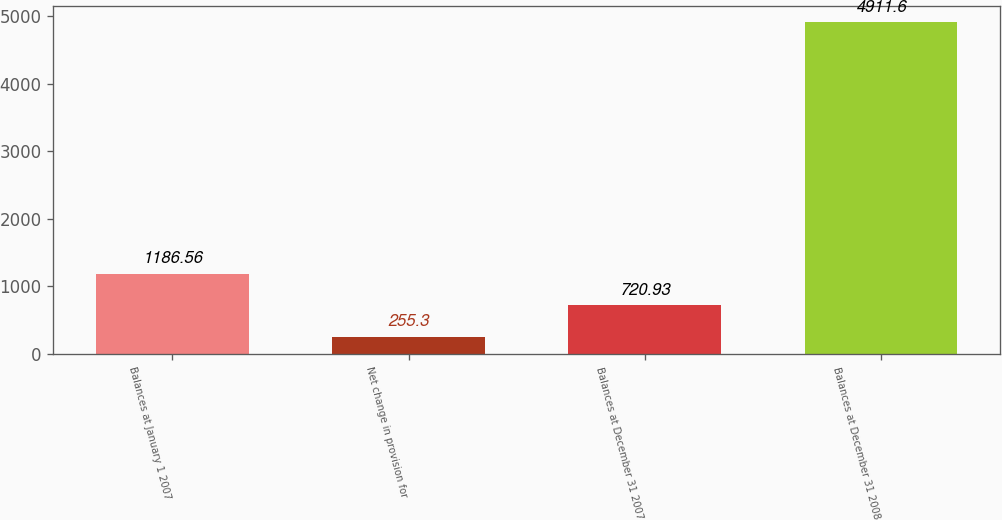Convert chart to OTSL. <chart><loc_0><loc_0><loc_500><loc_500><bar_chart><fcel>Balances at January 1 2007<fcel>Net change in provision for<fcel>Balances at December 31 2007<fcel>Balances at December 31 2008<nl><fcel>1186.56<fcel>255.3<fcel>720.93<fcel>4911.6<nl></chart> 